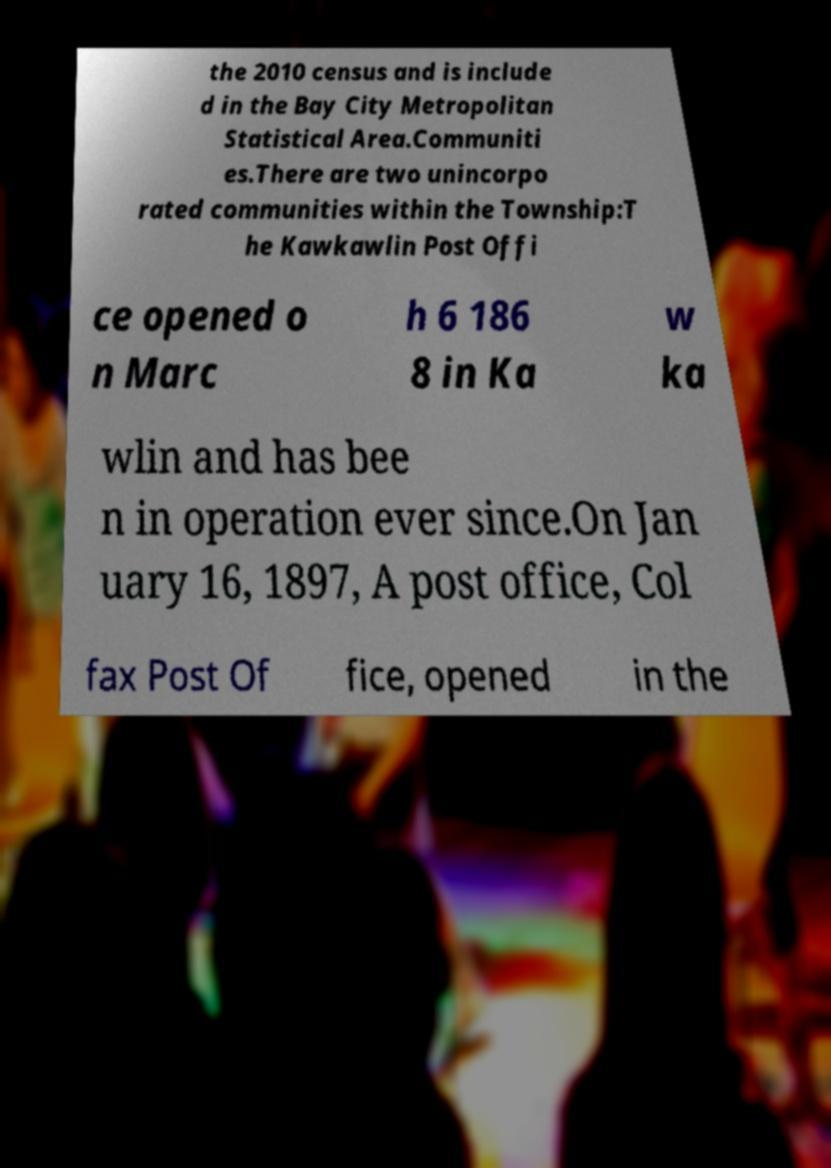For documentation purposes, I need the text within this image transcribed. Could you provide that? the 2010 census and is include d in the Bay City Metropolitan Statistical Area.Communiti es.There are two unincorpo rated communities within the Township:T he Kawkawlin Post Offi ce opened o n Marc h 6 186 8 in Ka w ka wlin and has bee n in operation ever since.On Jan uary 16, 1897, A post office, Col fax Post Of fice, opened in the 